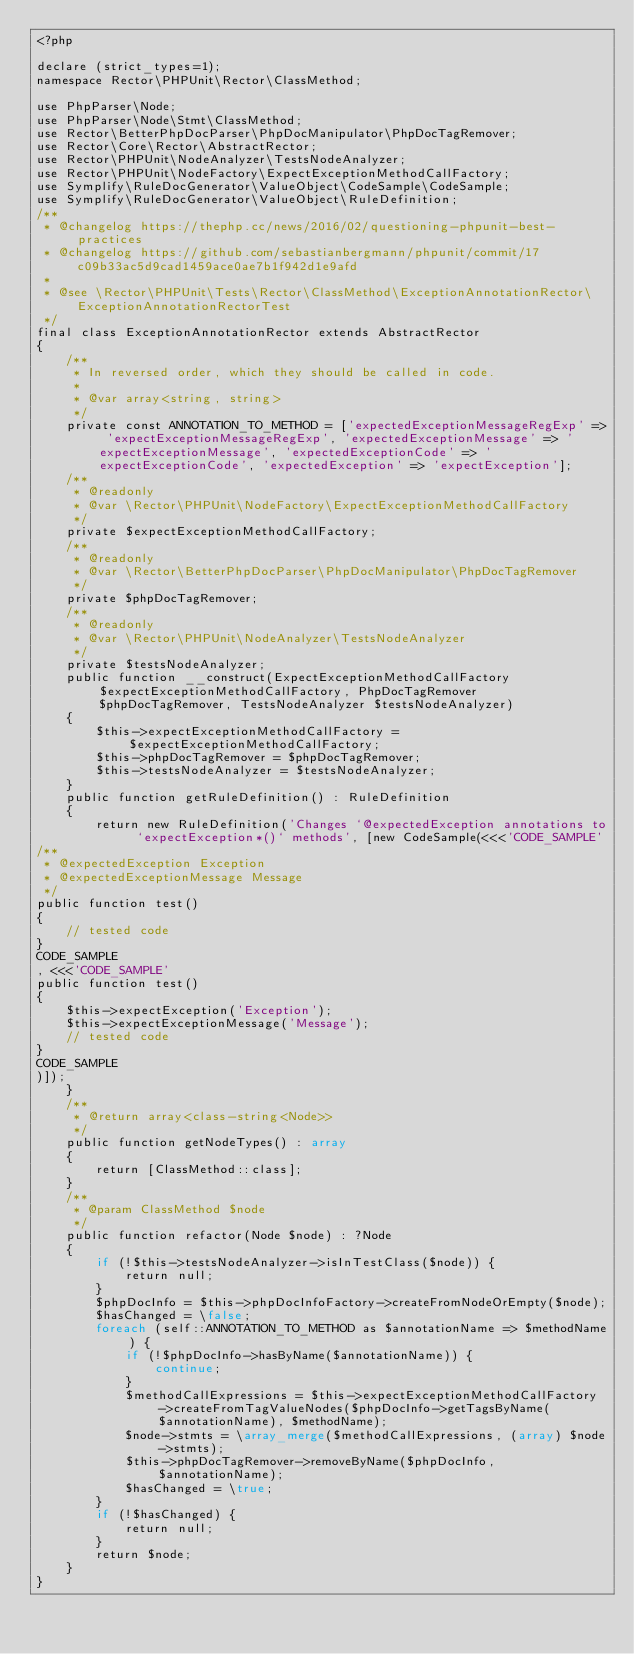<code> <loc_0><loc_0><loc_500><loc_500><_PHP_><?php

declare (strict_types=1);
namespace Rector\PHPUnit\Rector\ClassMethod;

use PhpParser\Node;
use PhpParser\Node\Stmt\ClassMethod;
use Rector\BetterPhpDocParser\PhpDocManipulator\PhpDocTagRemover;
use Rector\Core\Rector\AbstractRector;
use Rector\PHPUnit\NodeAnalyzer\TestsNodeAnalyzer;
use Rector\PHPUnit\NodeFactory\ExpectExceptionMethodCallFactory;
use Symplify\RuleDocGenerator\ValueObject\CodeSample\CodeSample;
use Symplify\RuleDocGenerator\ValueObject\RuleDefinition;
/**
 * @changelog https://thephp.cc/news/2016/02/questioning-phpunit-best-practices
 * @changelog https://github.com/sebastianbergmann/phpunit/commit/17c09b33ac5d9cad1459ace0ae7b1f942d1e9afd
 *
 * @see \Rector\PHPUnit\Tests\Rector\ClassMethod\ExceptionAnnotationRector\ExceptionAnnotationRectorTest
 */
final class ExceptionAnnotationRector extends AbstractRector
{
    /**
     * In reversed order, which they should be called in code.
     *
     * @var array<string, string>
     */
    private const ANNOTATION_TO_METHOD = ['expectedExceptionMessageRegExp' => 'expectExceptionMessageRegExp', 'expectedExceptionMessage' => 'expectExceptionMessage', 'expectedExceptionCode' => 'expectExceptionCode', 'expectedException' => 'expectException'];
    /**
     * @readonly
     * @var \Rector\PHPUnit\NodeFactory\ExpectExceptionMethodCallFactory
     */
    private $expectExceptionMethodCallFactory;
    /**
     * @readonly
     * @var \Rector\BetterPhpDocParser\PhpDocManipulator\PhpDocTagRemover
     */
    private $phpDocTagRemover;
    /**
     * @readonly
     * @var \Rector\PHPUnit\NodeAnalyzer\TestsNodeAnalyzer
     */
    private $testsNodeAnalyzer;
    public function __construct(ExpectExceptionMethodCallFactory $expectExceptionMethodCallFactory, PhpDocTagRemover $phpDocTagRemover, TestsNodeAnalyzer $testsNodeAnalyzer)
    {
        $this->expectExceptionMethodCallFactory = $expectExceptionMethodCallFactory;
        $this->phpDocTagRemover = $phpDocTagRemover;
        $this->testsNodeAnalyzer = $testsNodeAnalyzer;
    }
    public function getRuleDefinition() : RuleDefinition
    {
        return new RuleDefinition('Changes `@expectedException annotations to `expectException*()` methods', [new CodeSample(<<<'CODE_SAMPLE'
/**
 * @expectedException Exception
 * @expectedExceptionMessage Message
 */
public function test()
{
    // tested code
}
CODE_SAMPLE
, <<<'CODE_SAMPLE'
public function test()
{
    $this->expectException('Exception');
    $this->expectExceptionMessage('Message');
    // tested code
}
CODE_SAMPLE
)]);
    }
    /**
     * @return array<class-string<Node>>
     */
    public function getNodeTypes() : array
    {
        return [ClassMethod::class];
    }
    /**
     * @param ClassMethod $node
     */
    public function refactor(Node $node) : ?Node
    {
        if (!$this->testsNodeAnalyzer->isInTestClass($node)) {
            return null;
        }
        $phpDocInfo = $this->phpDocInfoFactory->createFromNodeOrEmpty($node);
        $hasChanged = \false;
        foreach (self::ANNOTATION_TO_METHOD as $annotationName => $methodName) {
            if (!$phpDocInfo->hasByName($annotationName)) {
                continue;
            }
            $methodCallExpressions = $this->expectExceptionMethodCallFactory->createFromTagValueNodes($phpDocInfo->getTagsByName($annotationName), $methodName);
            $node->stmts = \array_merge($methodCallExpressions, (array) $node->stmts);
            $this->phpDocTagRemover->removeByName($phpDocInfo, $annotationName);
            $hasChanged = \true;
        }
        if (!$hasChanged) {
            return null;
        }
        return $node;
    }
}
</code> 